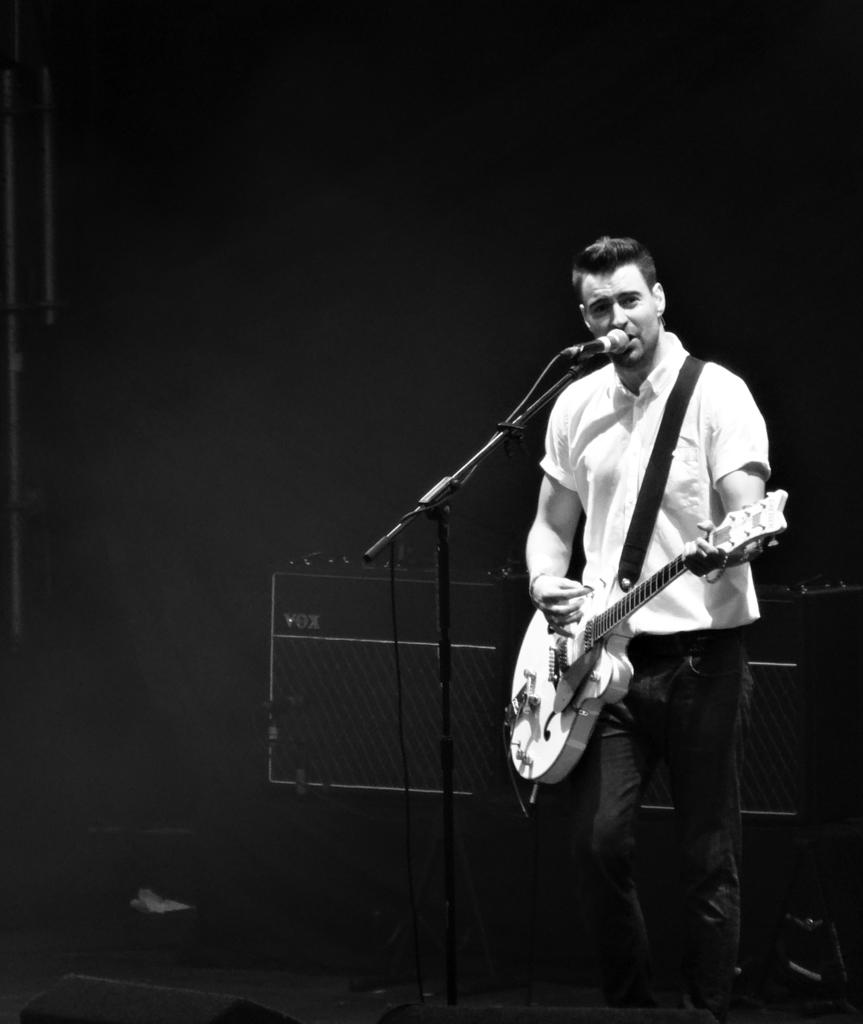What is the color scheme of the image? The image is black and white. What is the main subject of the image? There is a person in the image. What is the person holding? The person is holding a guitar. What is the person doing with the guitar? The person is singing. What other objects are present in the image? There is a microphone and a microphone stand in the image. Can you see any feathers or slopes in the image? No, there are no feathers or slopes present in the image. Is there a cobweb visible in the image? No, there is no cobweb visible in the image. 